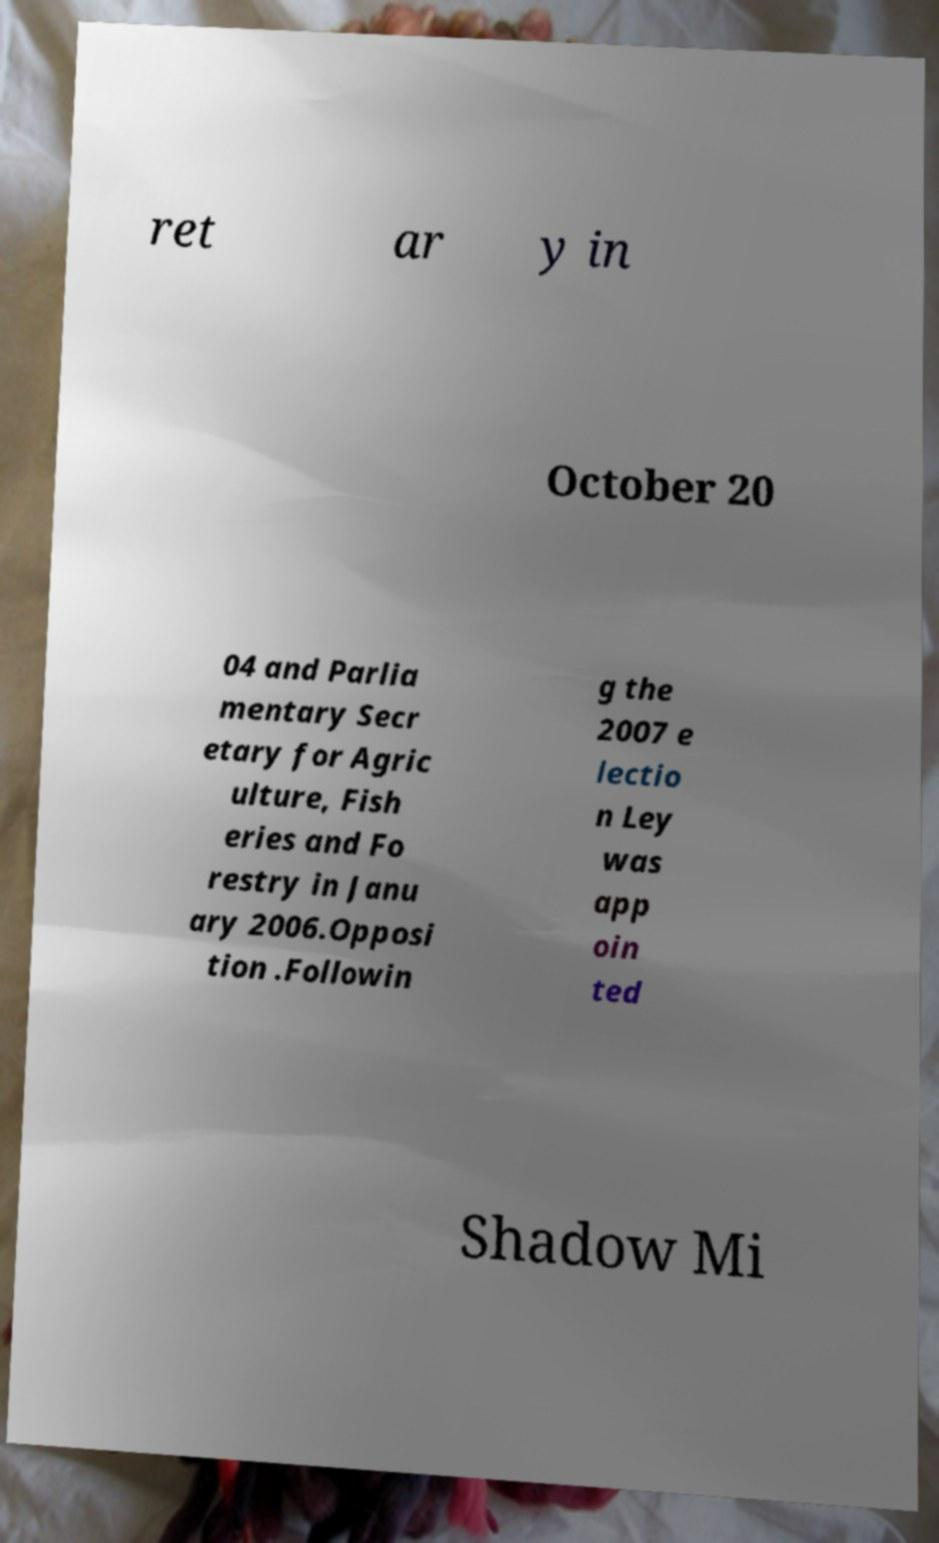For documentation purposes, I need the text within this image transcribed. Could you provide that? ret ar y in October 20 04 and Parlia mentary Secr etary for Agric ulture, Fish eries and Fo restry in Janu ary 2006.Opposi tion .Followin g the 2007 e lectio n Ley was app oin ted Shadow Mi 